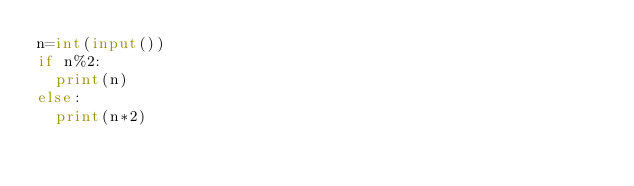Convert code to text. <code><loc_0><loc_0><loc_500><loc_500><_Python_>n=int(input())
if n%2:
  print(n)
else:
  print(n*2)</code> 